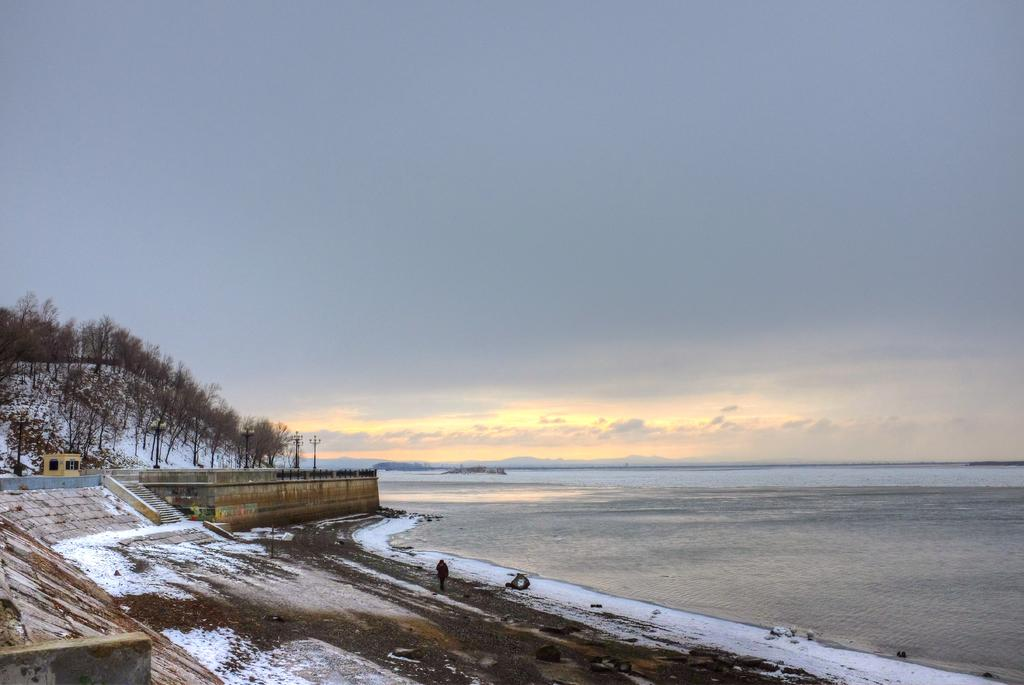What is the primary element visible in the image? There is water in the image. What type of structure can be seen in the image? There is a wall in the image. What type of vegetation is present in the image? There are trees in the image. What is the person in the image doing? The person is on the ground in the image. What can be seen in the background of the image? The sky is visible in the background of the image, and clouds are present in the sky. What type of party is being held in the image? There is no party present in the image. What type of lumber is being used to build the wall in the image? There is no lumber visible in the image, as the wall appears to be made of a different material. 